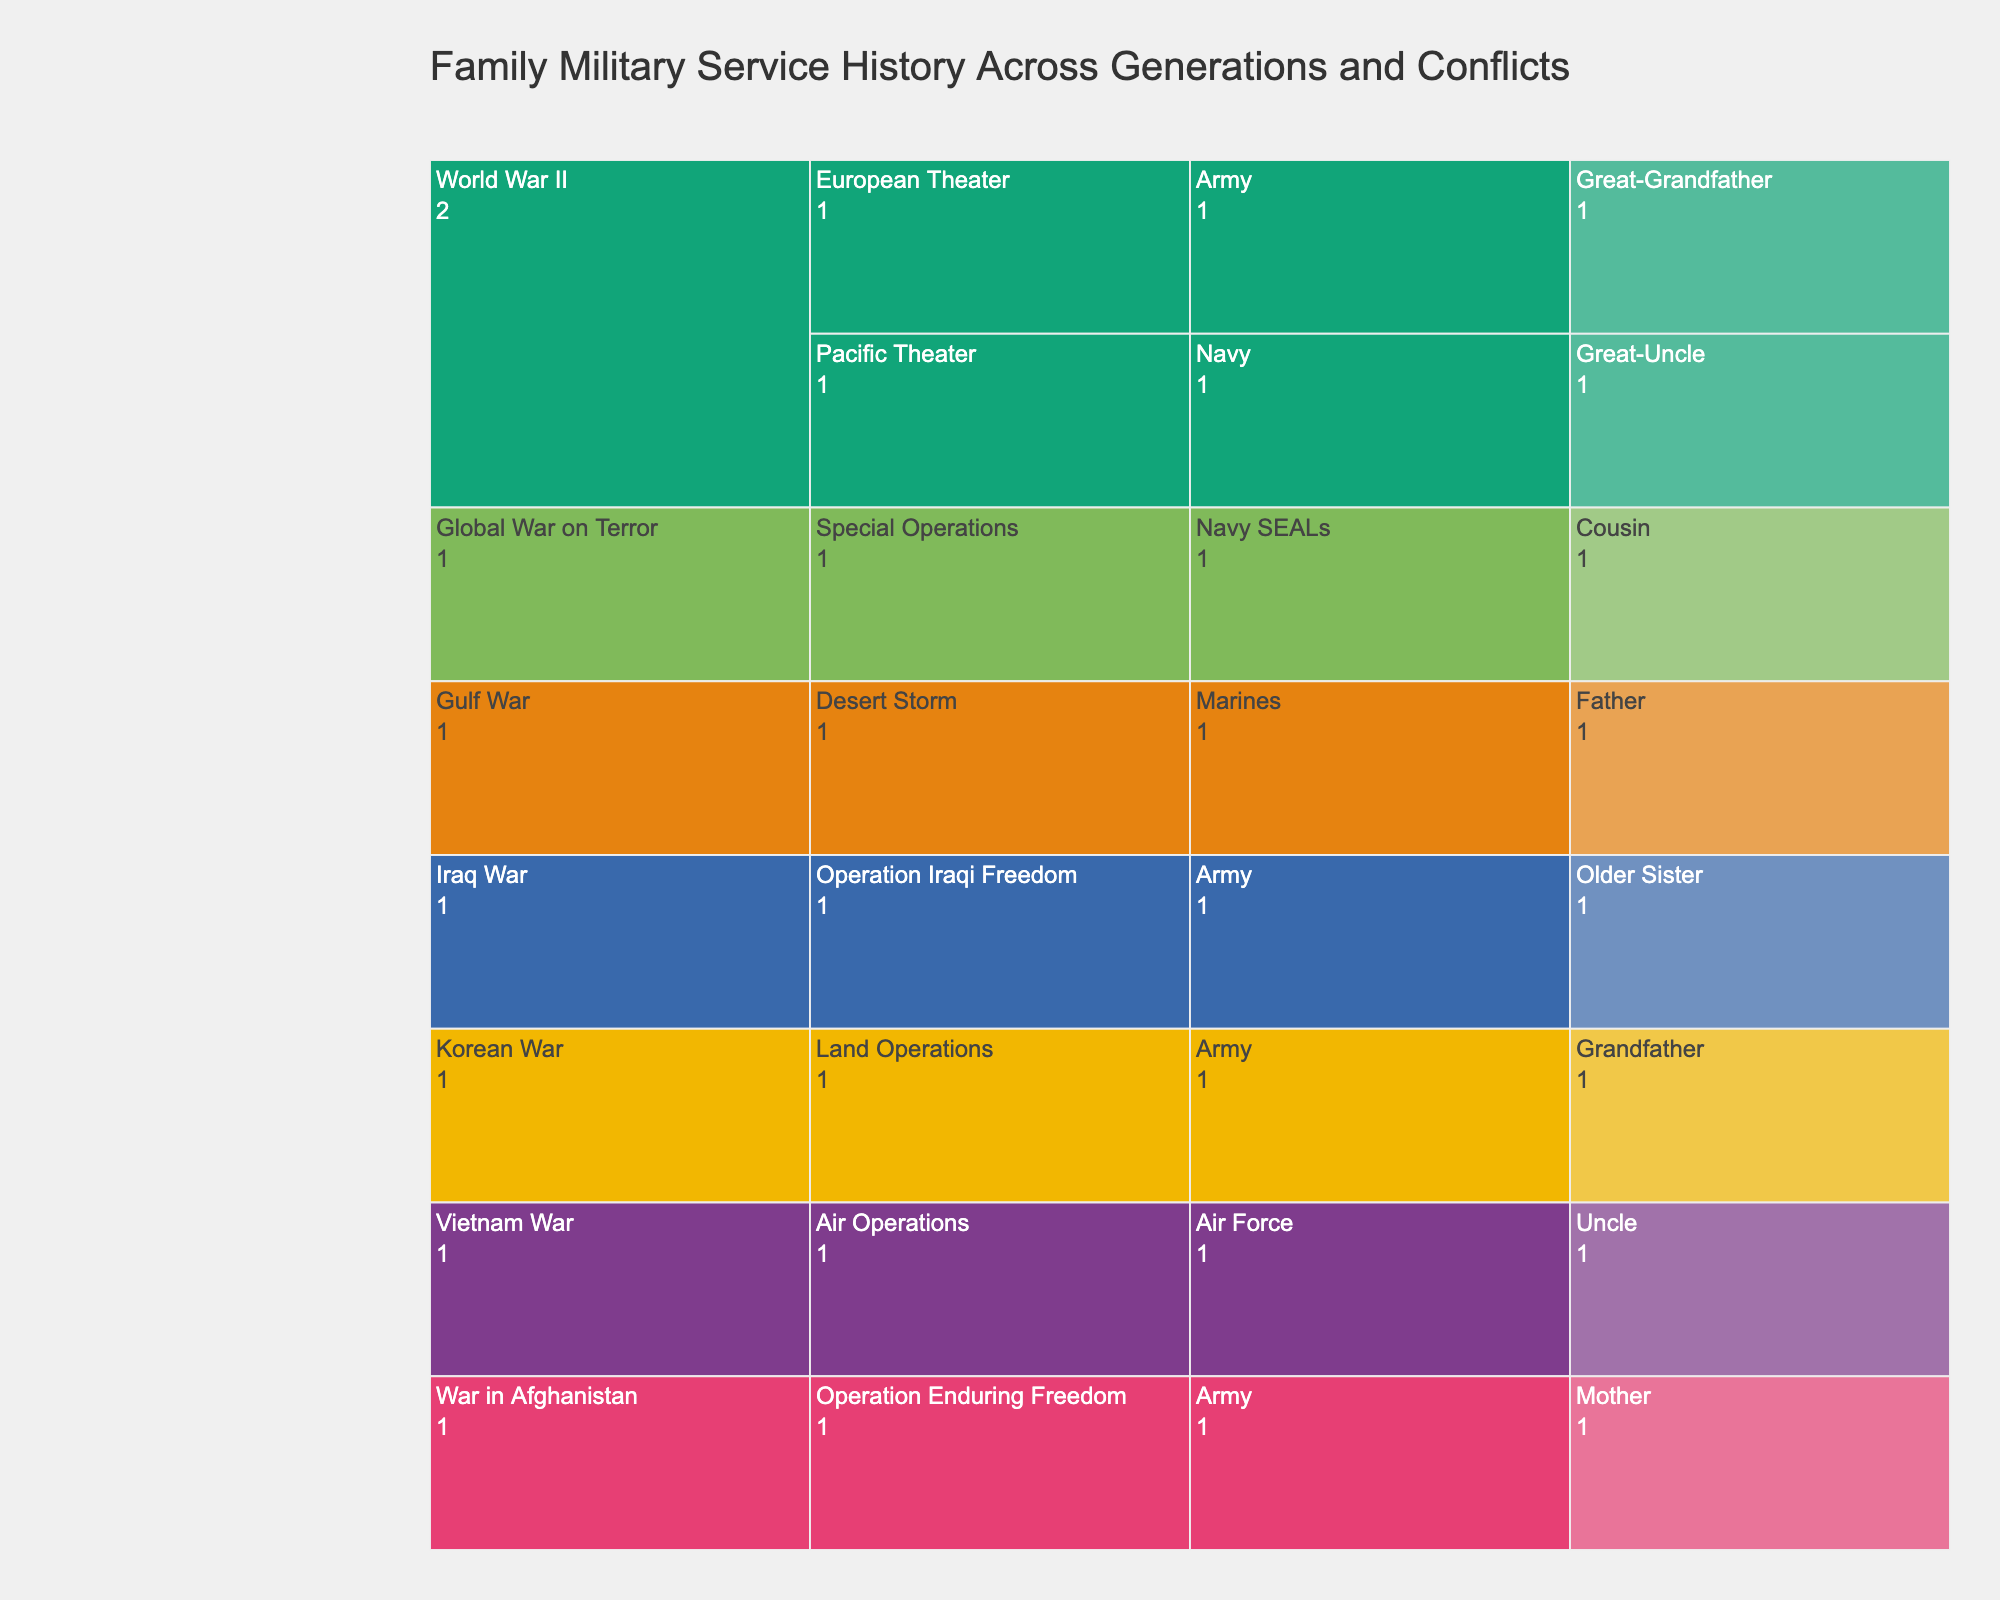What's the title of the figure? The title is usually displayed prominently at the top of the figure. By looking at the icicle chart, we can see the title written clearly.
Answer: Family Military Service History Across Generations and Conflicts How many generations are represented in the figure? To find out how many generations are represented, look at the top level of the icicle chart. Each unique label at this level represents a generation.
Answer: Four generations Which branch has the most family members represented in the icicle chart? Look at the branches listed under each conflict. Count the occurrences of each branch across all conflicts, then identify which one has the most occurrences.
Answer: Army Which conflict in the World War II generation involved the Navy? Look at the World War II generation, then examine the conflicts listed under it to find which one includes the Navy.
Answer: Pacific Theater Who served in the Gulf War and what was the name of their operation? Navigate to the Gulf War section in the icicle chart. Identify the family member listed and the specific operation they were involved in.
Answer: Father, Desert Storm Which family member served in the Air Force and during which conflict? Locate the Air Force under the branches and then identify which conflict it is listed under along with the family member's name.
Answer: Uncle, Vietnam War Compare the number of family members who served in the Army vs. Navy. Which is greater? By how much? Count the number of family members in the Army and Navy branches. Subtract the smaller count from the larger one to find the difference.
Answer: Army has 3 members, Navy has 2; Army by 1 What is the relationship between the family members who served in World War II? Look at the family members listed under World War II and identify their relationships based on the labels.
Answer: Great-Grandfather and Great-Uncle Who among the family served in the most recent conflict and what branch were they in? Identify the most recent conflict listed in the chart, then identify the family member and their branch.
Answer: Cousin, Navy SEALs How many conflicts are listed within the Vietnam War and Gulf War generations combined? Count the number of unique conflicts listed under both Vietnam War and Gulf War generations and add them together.
Answer: Two conflicts 